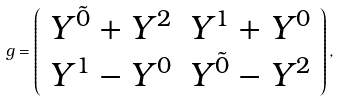<formula> <loc_0><loc_0><loc_500><loc_500>g = \left ( \begin{array} { c r } Y ^ { \tilde { 0 } } + Y ^ { 2 } & Y ^ { 1 } + Y ^ { 0 } \\ Y ^ { 1 } - Y ^ { 0 } & Y ^ { \tilde { 0 } } - Y ^ { 2 } \end{array} \right ) ,</formula> 